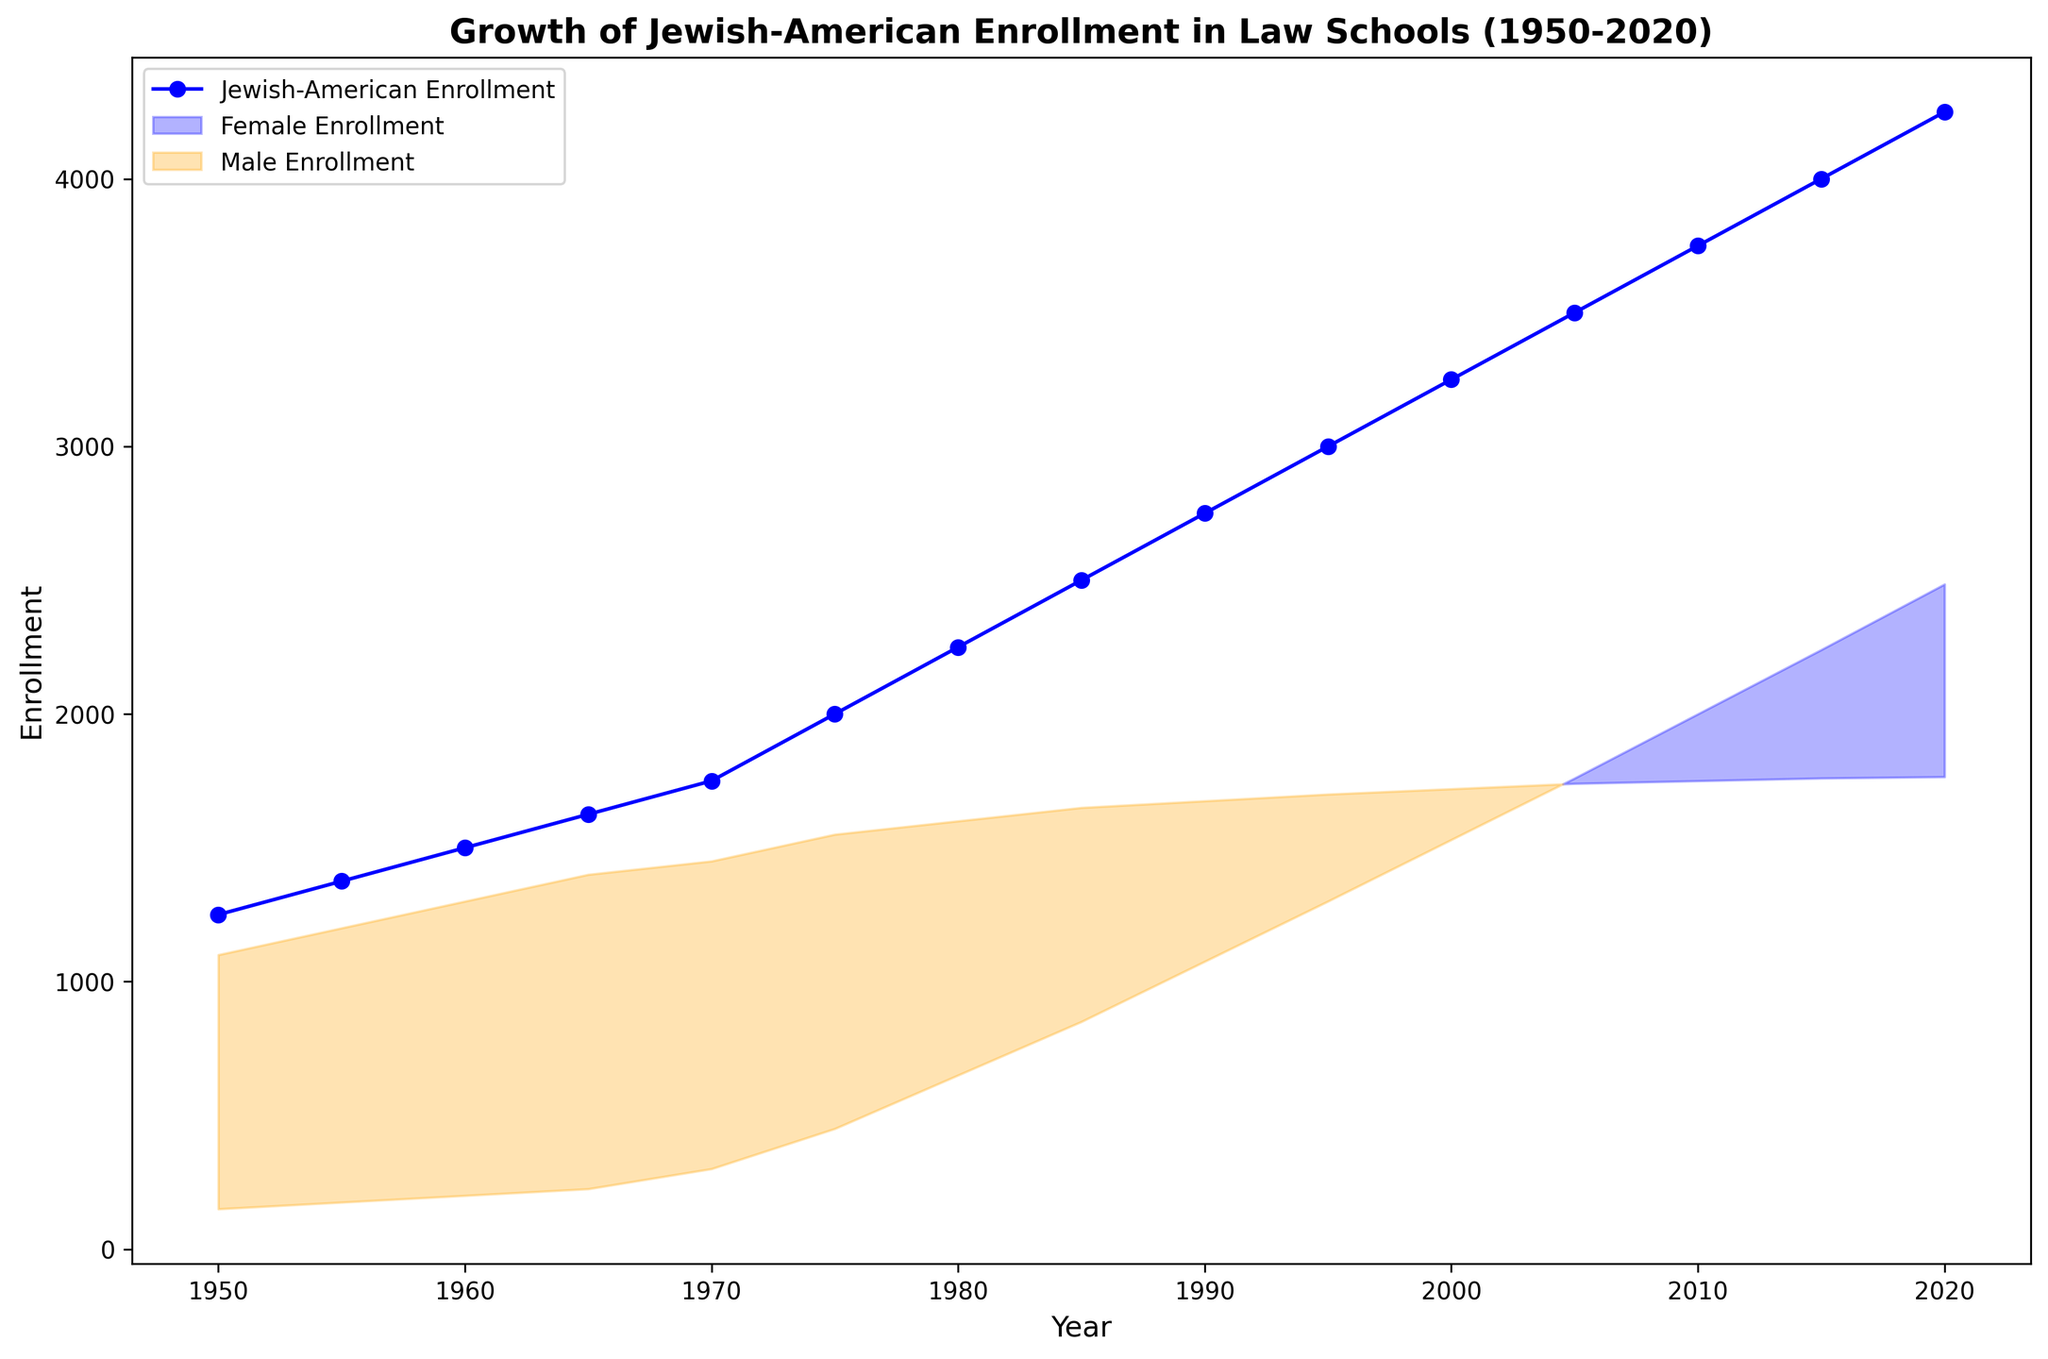What is the total enrollment value in 1975? Look at the plot and find the point on the x-axis corresponding to the year 1975, then trace upwards to where it intersects with the 'Jewish-American Enrollment' line. Read the value on the y-axis.
Answer: 2000 In which year did female Jewish-American enrollment first exceed male enrollment? Identify the two filled regions on the plot (blue for female, orange for male). The shift occurs where the blue region begins to be on top of the orange region. Locate the corresponding year on the x-axis.
Answer: 1980 What is the difference in Jewish-American enrollment between 1970 and 1980? Find the enrollment values for 1970 and 1980 on the y-axis, then subtract the 1970 value from the 1980 value.
Answer: 500 During which decade did Jewish-American female enrollment grow the most? Observe the blue filled area and look for the steepest increase visually across decades. Note which decade shows the largest visual expansion of the blue area.
Answer: 1970s How many more females were enrolled than males in 2020? At the point for 2020 on the x-axis, find the respective female and male enrollment values on the y-axis. Subtract the male value from the female value.
Answer: 720 In what year did Jewish-American enrollment reach 3000? Locate the point where the y-axis value for Jewish-American enrollment is 3000, then trace it back to the corresponding year on the x-axis.
Answer: 1995 Compare the Jewish-American enrollment in 1950 with the enrollment in 2000. Which is higher and by how much? Find the enrollment values for both years and perform the subtraction. Subtract the 1950 value from the 2000 value.
Answer: 2000, 2000 higher What was the percentage increase in total enrollment from 1950 to 2020? Identify the total enrollment values for both years. Calculate the percentage increase using the formula: ((value in 2020 - value in 1950) / value in 1950) * 100.
Answer: 240% What proportion of Jewish-American law students were female in 1990? Find the values for male and female enrollment in 1990. Calculate the proportion using the formula: (female / (male + female)).
Answer: 0.39 (approximately 39%) When did the total Jewish-American enrollment double from its 1950 value? Identify the enrollment value in 1950 and multiply by 2 to find the doubled value. Trace to the year on the x-axis where the Jewish-American enrollment intersects this value.
Answer: 1980 